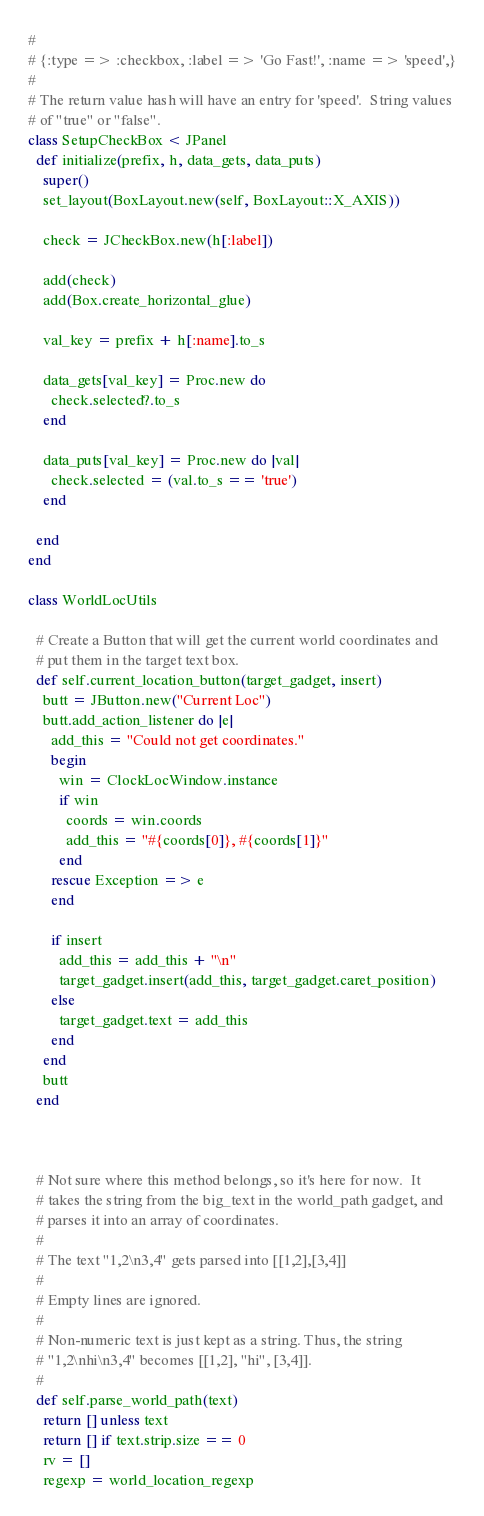Convert code to text. <code><loc_0><loc_0><loc_500><loc_500><_Ruby_># 
# {:type => :checkbox, :label => 'Go Fast!', :name => 'speed',}
#
# The return value hash will have an entry for 'speed'.  String values
# of "true" or "false".
class SetupCheckBox < JPanel
  def initialize(prefix, h, data_gets, data_puts)
    super()
    set_layout(BoxLayout.new(self, BoxLayout::X_AXIS))

    check = JCheckBox.new(h[:label])

    add(check)
    add(Box.create_horizontal_glue)

    val_key = prefix + h[:name].to_s

    data_gets[val_key] = Proc.new do
      check.selected?.to_s
    end
    
    data_puts[val_key] = Proc.new do |val|
      check.selected = (val.to_s == 'true')
    end

  end
end

class WorldLocUtils

  # Create a Button that will get the current world coordinates and
  # put them in the target text box.
  def self.current_location_button(target_gadget, insert)
    butt = JButton.new("Current Loc")
    butt.add_action_listener do |e|
      add_this = "Could not get coordinates."
      begin
        win = ClockLocWindow.instance
        if win 
          coords = win.coords
          add_this = "#{coords[0]}, #{coords[1]}"
        end
      rescue Exception => e
      end

      if insert
        add_this = add_this + "\n"
        target_gadget.insert(add_this, target_gadget.caret_position)
      else
        target_gadget.text = add_this
      end
    end
    butt
  end


  
  # Not sure where this method belongs, so it's here for now.  It
  # takes the string from the big_text in the world_path gadget, and
  # parses it into an array of coordinates.
  # 
  # The text "1,2\n3,4" gets parsed into [[1,2],[3,4]] 
  # 
  # Empty lines are ignored.  
  # 
  # Non-numeric text is just kept as a string. Thus, the string
  # "1,2\nhi\n3,4" becomes [[1,2], "hi", [3,4]].
  #
  def self.parse_world_path(text)
    return [] unless text
    return [] if text.strip.size == 0
    rv = []
    regexp = world_location_regexp</code> 